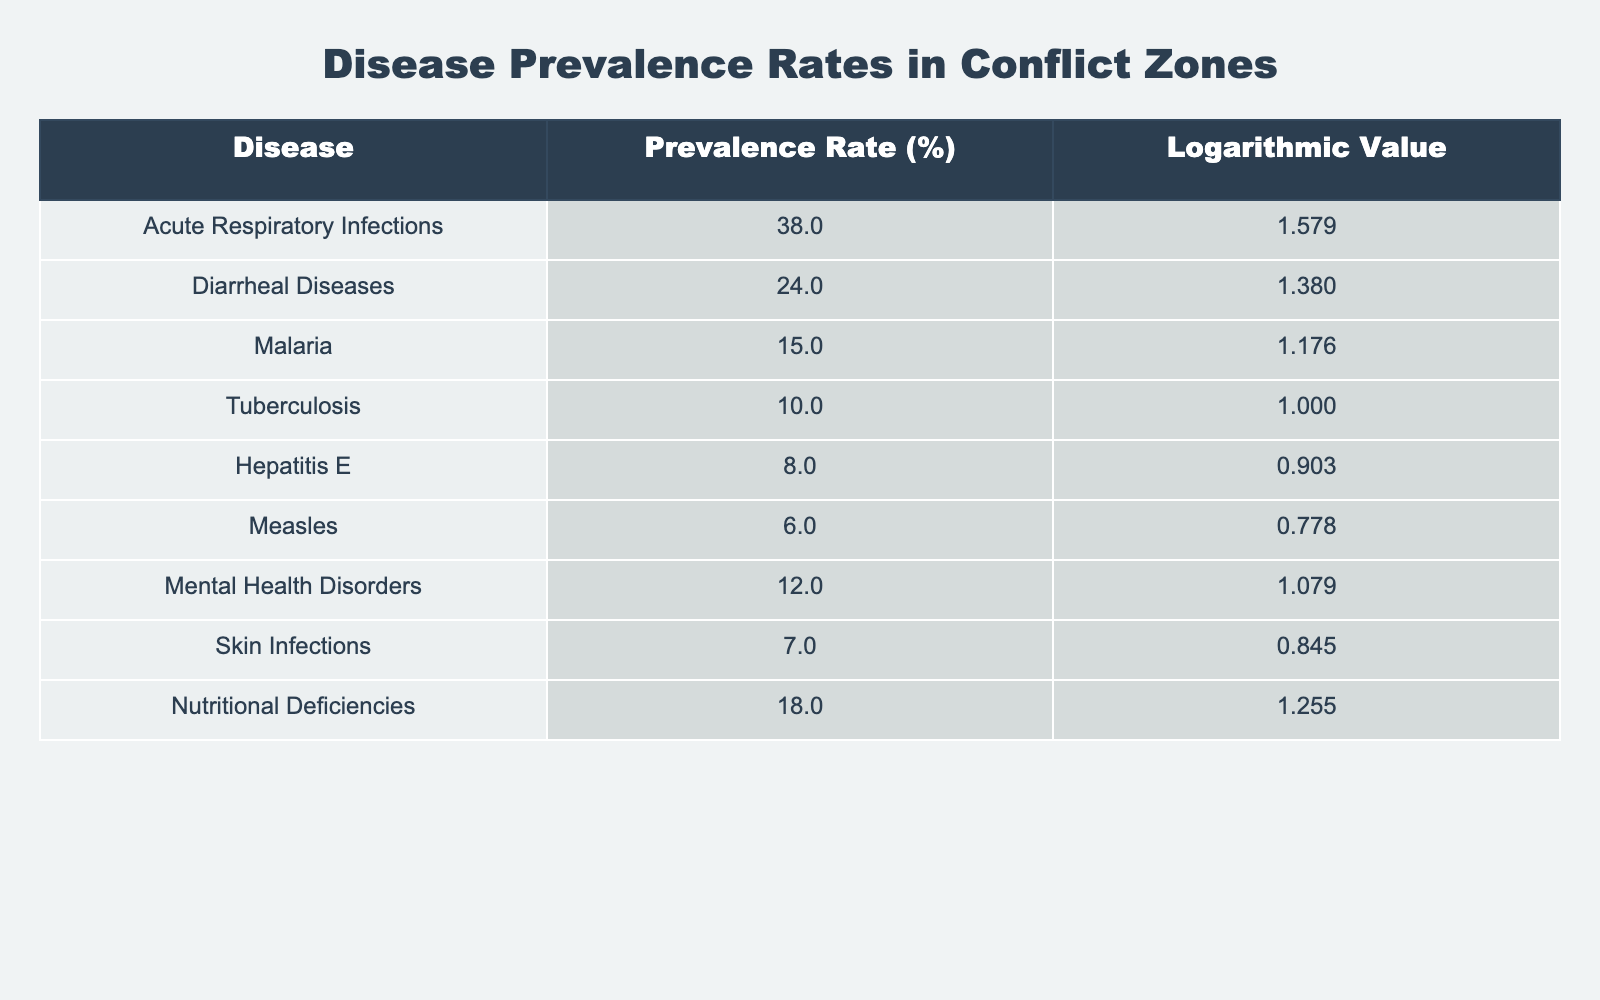What is the prevalence rate of Acute Respiratory Infections? According to the table, the prevalence rate for Acute Respiratory Infections is directly listed as 38%.
Answer: 38% Which disease has the lowest prevalence rate? Looking at the prevalence rates in the table, Measles has the lowest rate listed at 6%.
Answer: 6% What is the combined prevalence rate of Diarrheal Diseases and Measles? Diarrheal Diseases has a prevalence rate of 24%, and Measles has a rate of 6%. Summing these values gives us 24% + 6% = 30%.
Answer: 30% Is the prevalence rate of Tuberculosis higher than that of Hepatitis E? The table shows Tuberculosis with a prevalence of 10% and Hepatitis E with a prevalence of 8%. Since 10% is greater than 8%, the statement is true.
Answer: Yes What is the average prevalence rate of all listed diseases? To find the average, add all the prevalence rates: 38 + 24 + 15 + 10 + 8 + 6 + 12 + 7 + 18 = 138. There are 9 diseases, so divide the sum by 9: 138 / 9 = 15.33%.
Answer: 15.3% Which disease has a logarithmic value closest to 1 and what is its prevalence rate? The disease with a logarithmic value closest to 1 is Tuberculosis, which has a logarithmic value of 1.000 and a prevalence rate of 10%.
Answer: Tuberculosis, 10% What is the difference in prevalence rates between Nutritional Deficiencies and Mental Health Disorders? Nutritional Deficiencies has a prevalence rate of 18%, and Mental Health Disorders has a rate of 12%. The difference is calculated as 18% - 12% = 6%.
Answer: 6% Are there more diseases with a prevalence rate above 10% or below 10%? The table lists 5 diseases above 10% (Acute Respiratory Infections, Diarrheal Diseases, Malaria, Mental Health Disorders, Nutritional Deficiencies) and 4 diseases at or below 10% (Tuberculosis, Hepatitis E, Measles, Skin Infections). Thus, there are more diseases above 10%.
Answer: Above 10% What is the difference between the prevalence rates of the disease with the highest and lowest rates? The disease with the highest rate is Acute Respiratory Infections at 38%, and the lowest is Measles at 6%. The difference is 38% - 6% = 32%.
Answer: 32% 